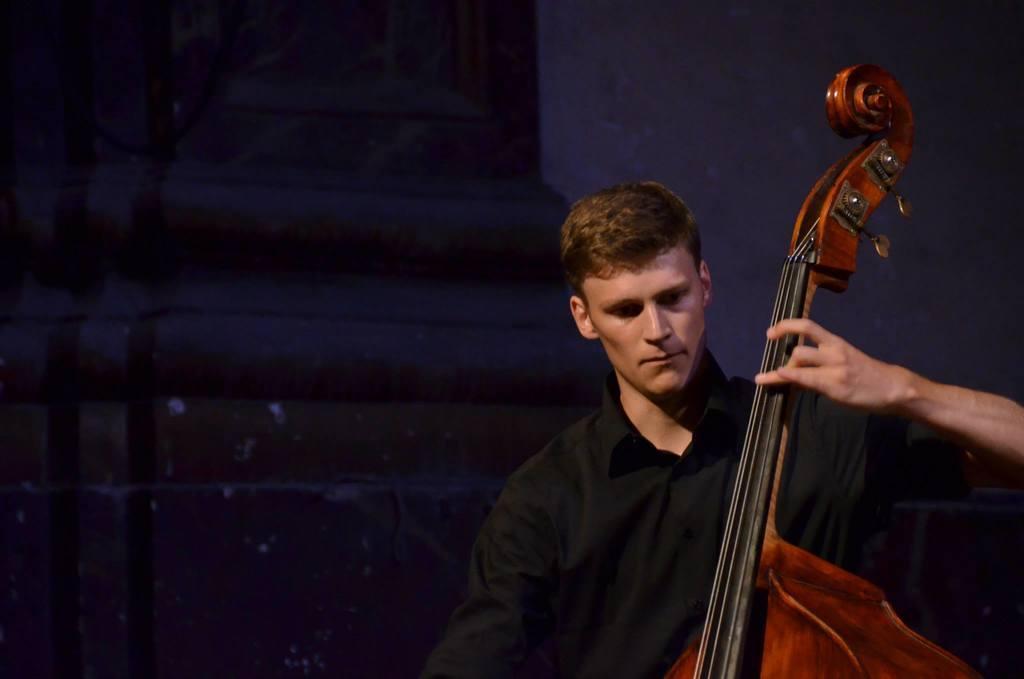Describe this image in one or two sentences. In this image I can see the person playing the musical instrument. There is a person wearing the black color dress. 